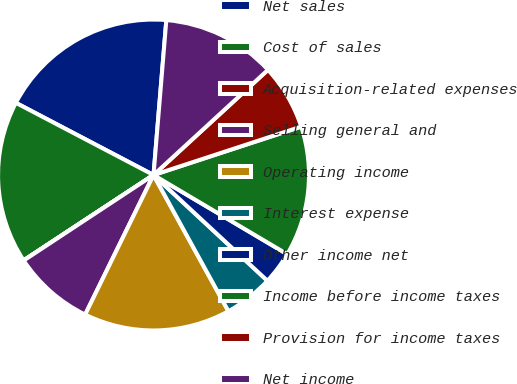Convert chart to OTSL. <chart><loc_0><loc_0><loc_500><loc_500><pie_chart><fcel>Net sales<fcel>Cost of sales<fcel>Acquisition-related expenses<fcel>Selling general and<fcel>Operating income<fcel>Interest expense<fcel>Other income net<fcel>Income before income taxes<fcel>Provision for income taxes<fcel>Net income<nl><fcel>18.63%<fcel>16.94%<fcel>0.02%<fcel>8.48%<fcel>15.25%<fcel>5.09%<fcel>3.4%<fcel>13.55%<fcel>6.79%<fcel>11.86%<nl></chart> 